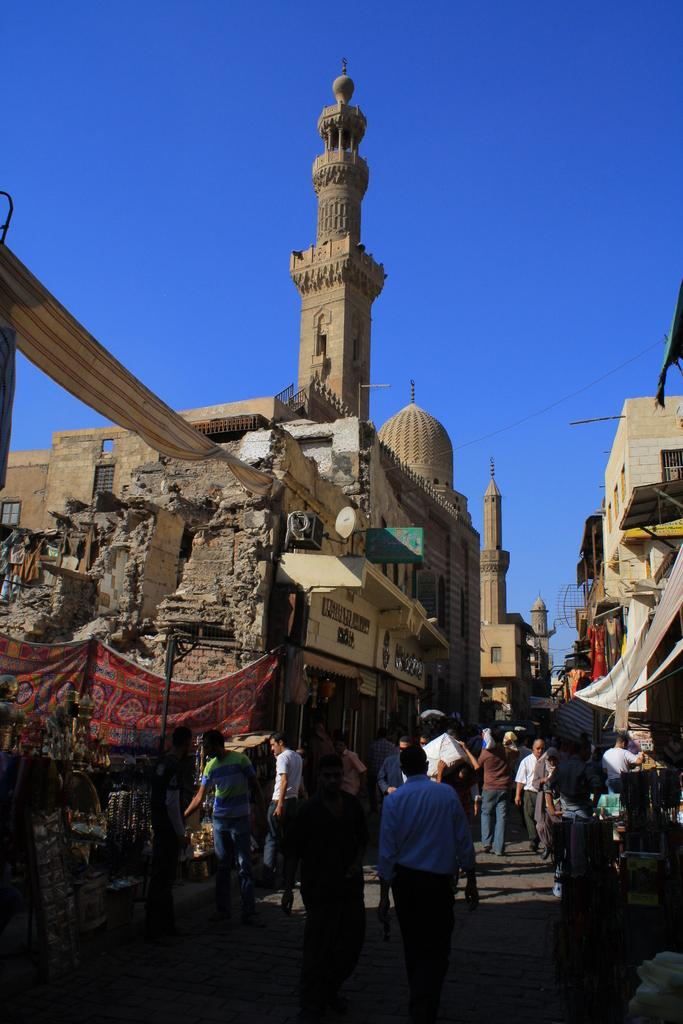What structures are located in the middle of the image? There are buildings in the middle of the image. What are the people in the image doing? There are persons walking at the bottom of the image. What is visible at the top of the image? The sky is visible at the top of the image. Where is the door to the bath located in the image? There is no bath or door present in the image. What type of drug can be seen in the image? There is no drug present in the image. 